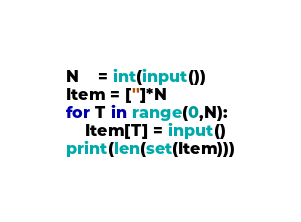Convert code to text. <code><loc_0><loc_0><loc_500><loc_500><_Python_>N    = int(input())
Item = ['']*N
for T in range(0,N):
    Item[T] = input()
print(len(set(Item)))</code> 